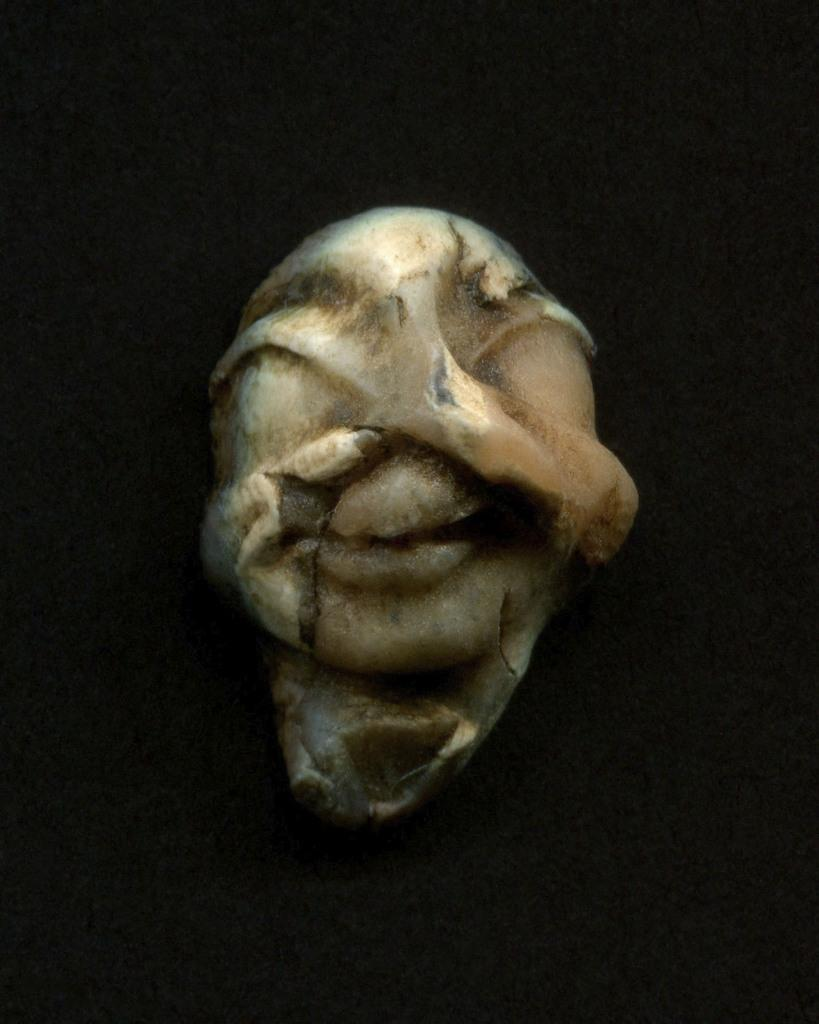What is the main subject of the image? The main subject of the image is an object that looks like a stone. What can be seen in the background of the image? The background of the image is dark. What type of wound can be seen on the stone in the image? There is no wound present on the stone in the image, as it is an inanimate object. 